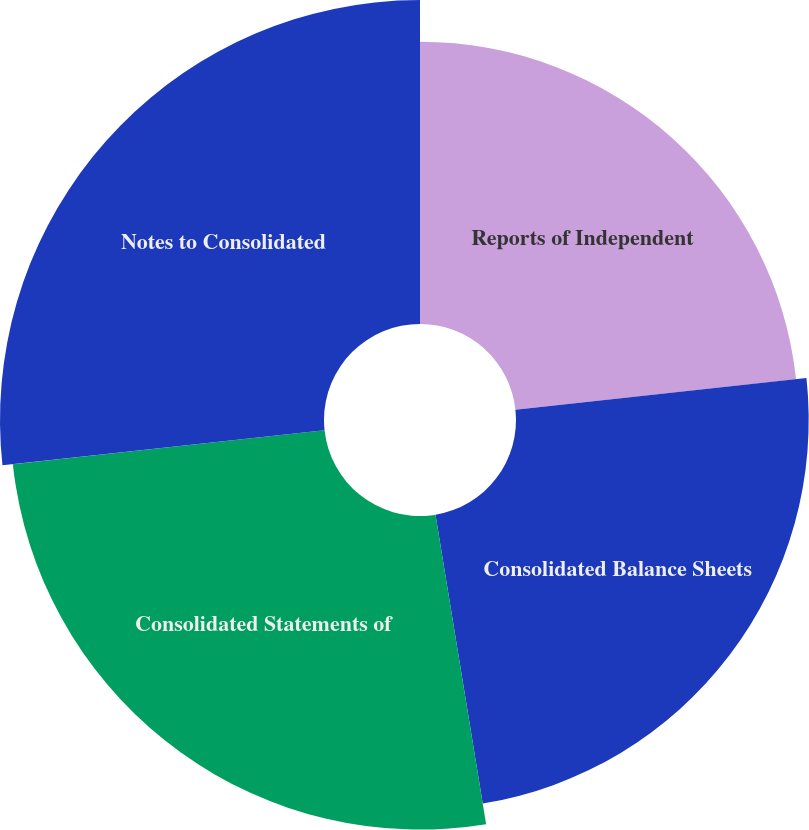<chart> <loc_0><loc_0><loc_500><loc_500><pie_chart><fcel>Reports of Independent<fcel>Consolidated Balance Sheets<fcel>Consolidated Statements of<fcel>Notes to Consolidated<nl><fcel>23.28%<fcel>24.14%<fcel>25.86%<fcel>26.72%<nl></chart> 